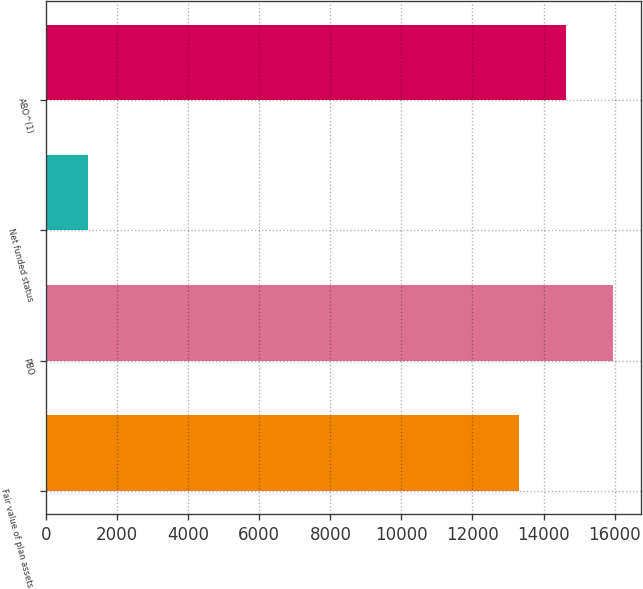<chart> <loc_0><loc_0><loc_500><loc_500><bar_chart><fcel>Fair value of plan assets<fcel>PBO<fcel>Net funded status<fcel>ABO^(1)<nl><fcel>13295<fcel>15954<fcel>1189<fcel>14624.5<nl></chart> 